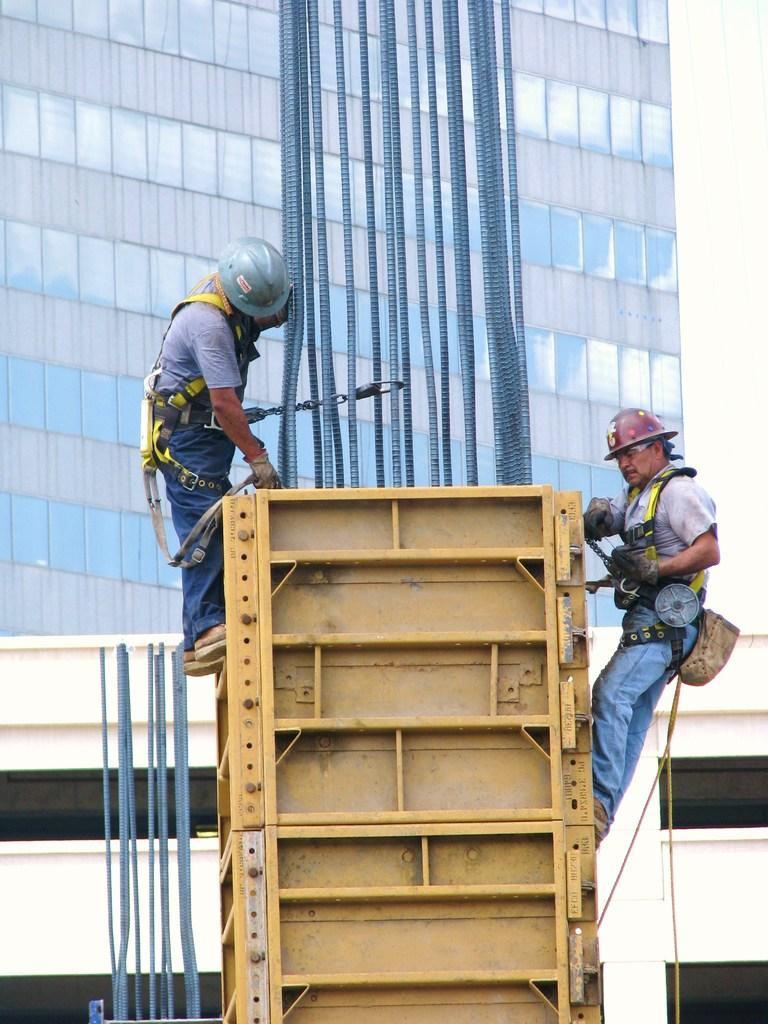What are the men doing in the image? The men are standing on a construction crane. What can be seen in the background of the image? There are buildings in the background of the image. How many legs can be seen on the family in the image? There is no family present in the image, and therefore no legs can be counted. 